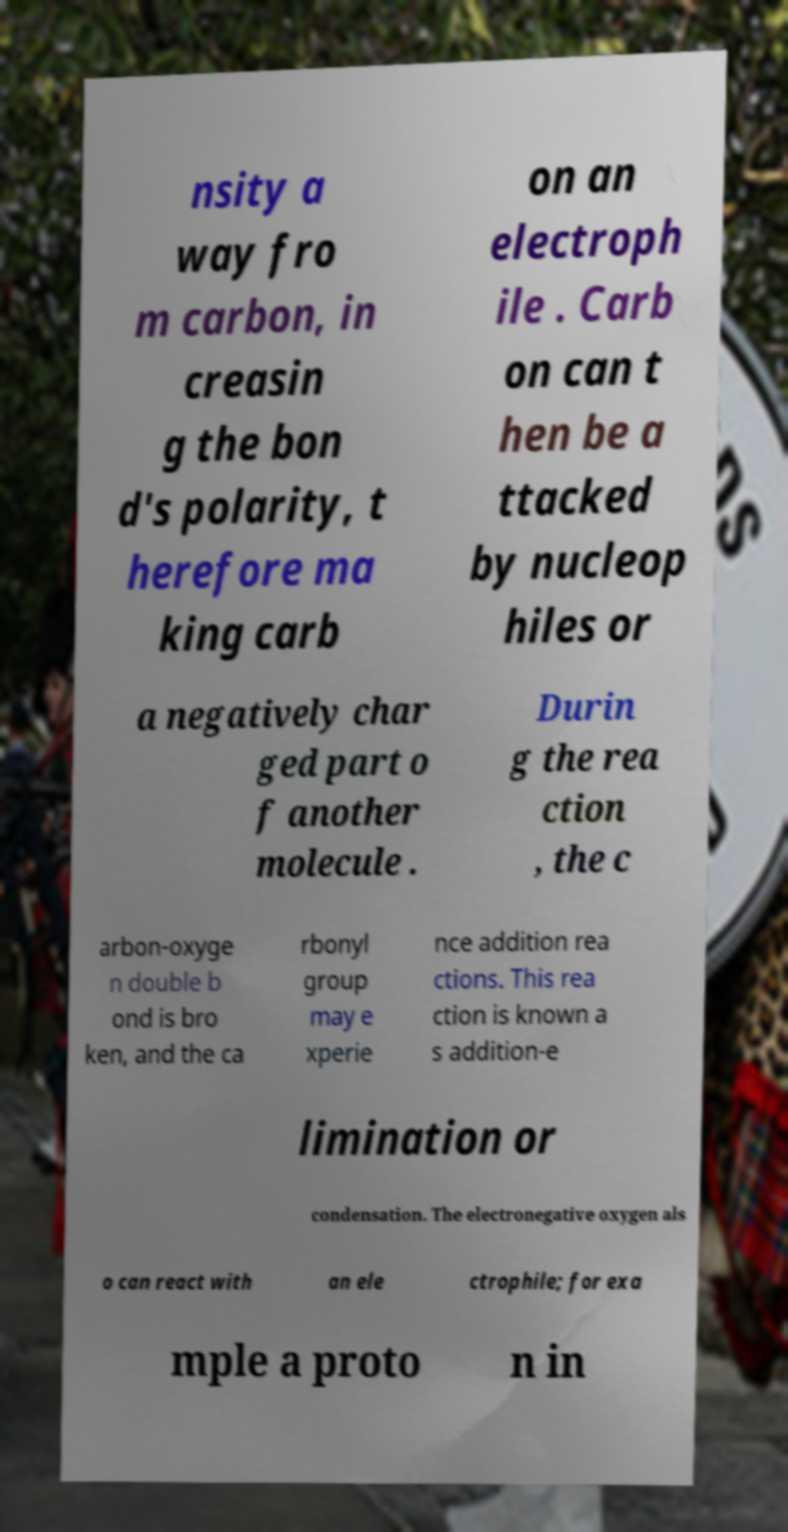Please read and relay the text visible in this image. What does it say? nsity a way fro m carbon, in creasin g the bon d's polarity, t herefore ma king carb on an electroph ile . Carb on can t hen be a ttacked by nucleop hiles or a negatively char ged part o f another molecule . Durin g the rea ction , the c arbon-oxyge n double b ond is bro ken, and the ca rbonyl group may e xperie nce addition rea ctions. This rea ction is known a s addition-e limination or condensation. The electronegative oxygen als o can react with an ele ctrophile; for exa mple a proto n in 